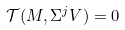Convert formula to latex. <formula><loc_0><loc_0><loc_500><loc_500>\mathcal { T } ( M , \Sigma ^ { j } V ) = 0</formula> 